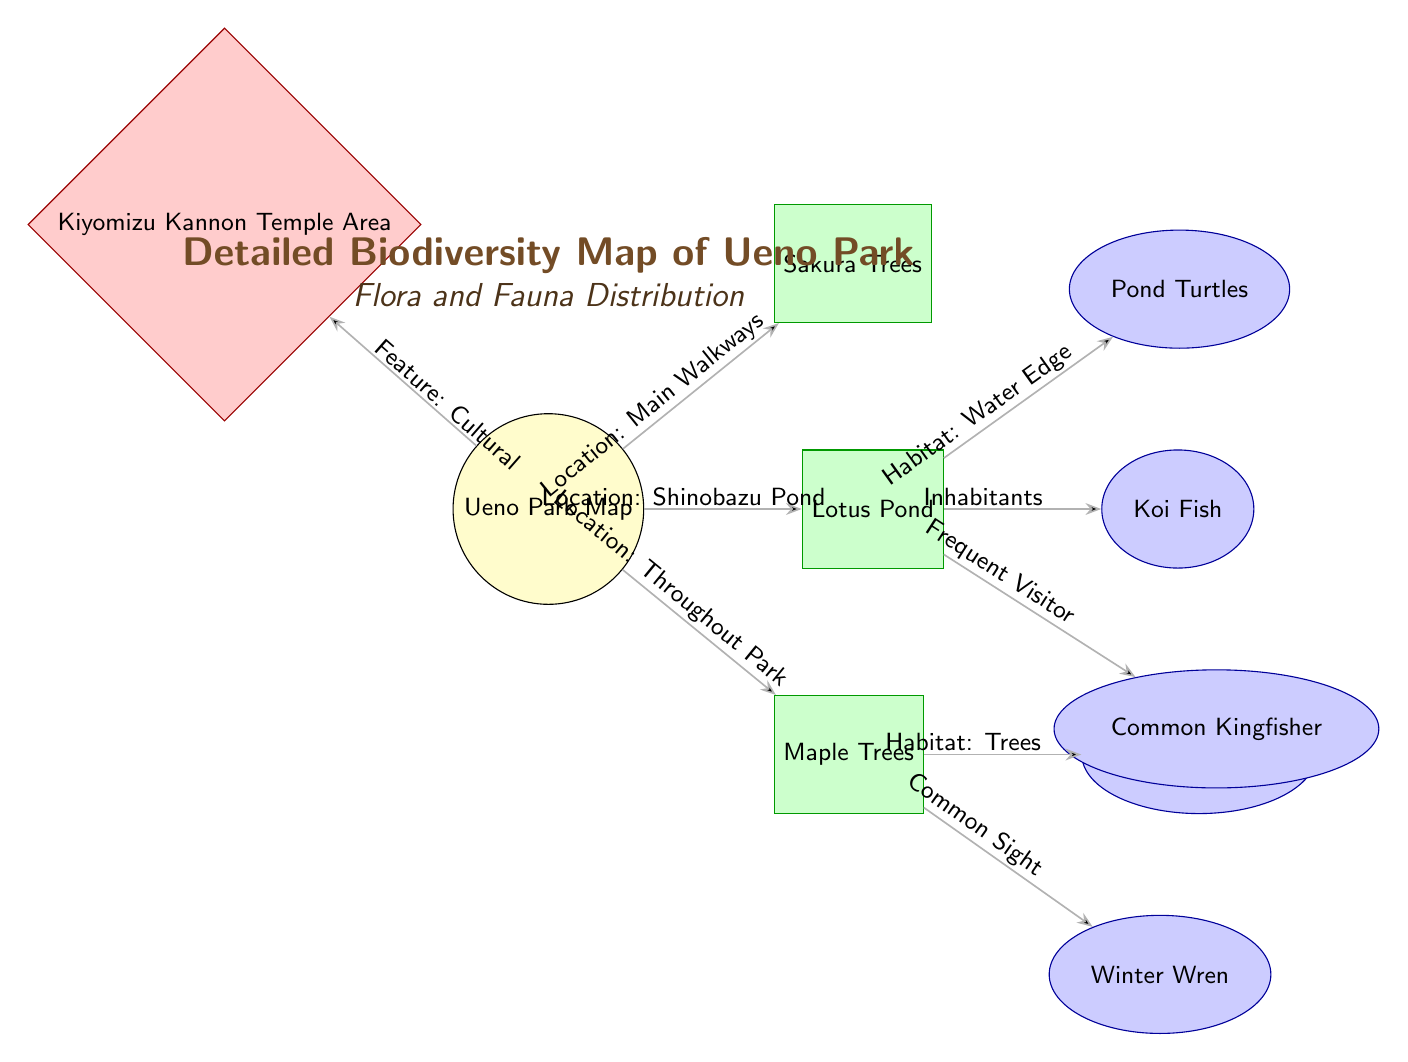What are the main types of flora shown on the map? The diagram lists three types of flora: Sakura Trees, Lotus Pond, and Maple Trees.
Answer: Sakura Trees, Lotus Pond, Maple Trees How many types of fauna are represented in the diagram? There are four types of fauna: Pond Turtles, Koi Fish, Avian Species, and Winter Wren, plus Common Kingfisher. Counting these gives a total of five types.
Answer: Five What is the habitat for the Koi Fish? The diagram indicates the Koi Fish's habitat as the Water Edge, as it is connected to the Lotus Pond, which is the associated location for Koi Fish.
Answer: Water Edge Which area is noted for its cultural feature? The Kiyomizu Kannon Temple Area is indicated as a location with a cultural feature connected to the Ueno Park map.
Answer: Kiyomizu Kannon Temple Area What type of relationship does the Common Kingfisher have with the diagram? The Common Kingfisher is labeled as a Frequent Visitor, showing its relationship to the habitat near the Lotus Pond through its connection in the diagram.
Answer: Frequent Visitor What is the relationship between Maple Trees and Avian Species? Avian Species are indicated to inhabit areas associated with Maple Trees, which indicates a direct habitat relationship.
Answer: Habitat: Trees How many locations are identified in the diagram? The diagram illustrates two distinct locations: Kiyomizu Kannon Temple Area and Shinobazu Pond, contributing to a total of three locations on the map, including main walkways.
Answer: Three What is the predominant color scheme for flora nodes? The flora nodes in the diagram are primarily colored green, indicating their classification in the map.
Answer: Green Which fauna is specifically noted for being located in the vicinity of Shinobazu Pond? Pond Turtles are specifically noted for their habitat relationship with the environment of Shinobazu Pond in the diagram.
Answer: Pond Turtles 